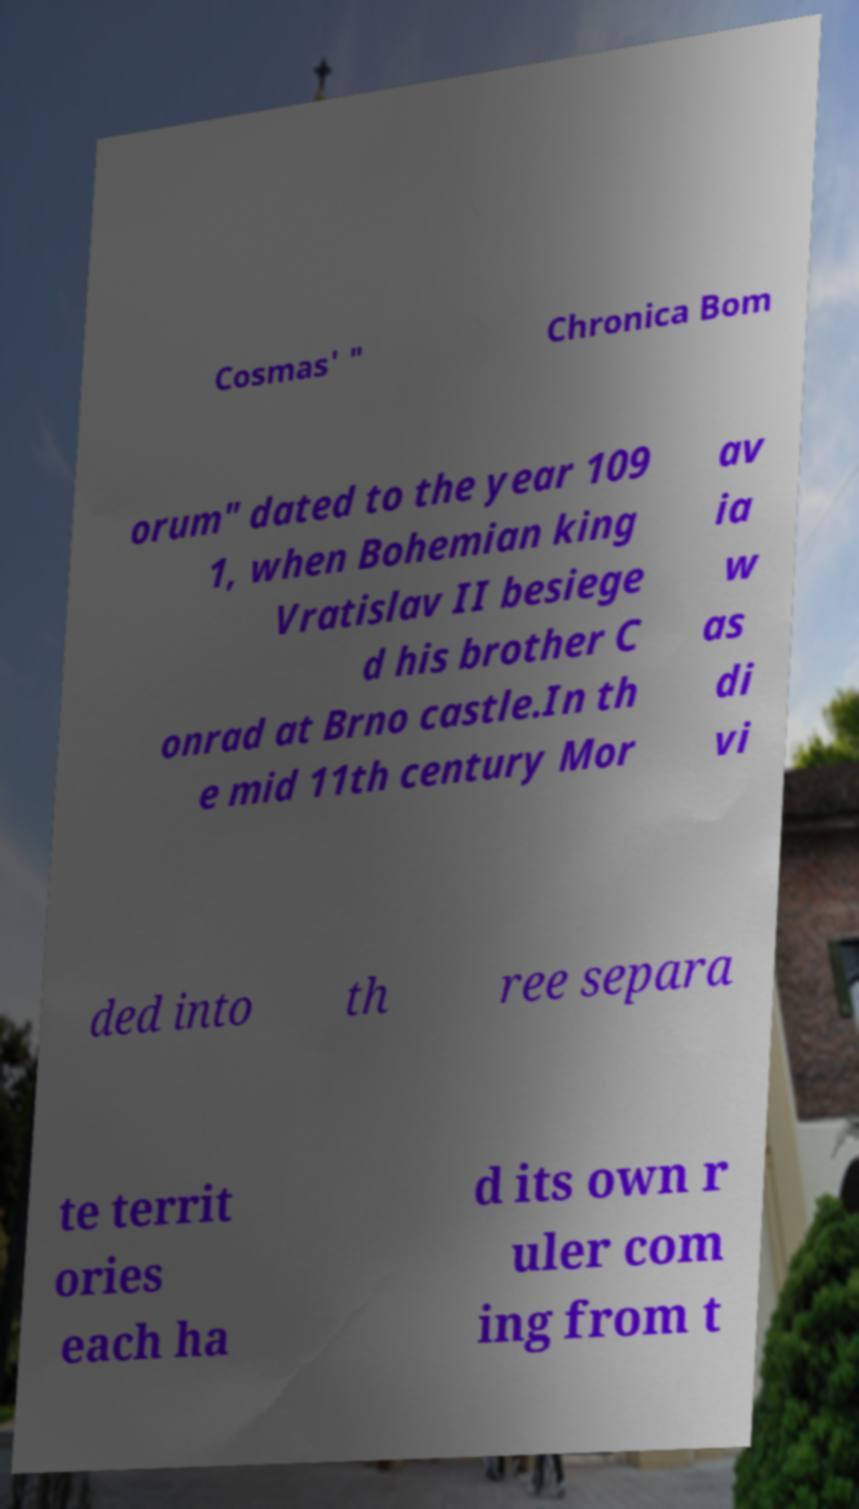Could you extract and type out the text from this image? Cosmas' " Chronica Bom orum" dated to the year 109 1, when Bohemian king Vratislav II besiege d his brother C onrad at Brno castle.In th e mid 11th century Mor av ia w as di vi ded into th ree separa te territ ories each ha d its own r uler com ing from t 